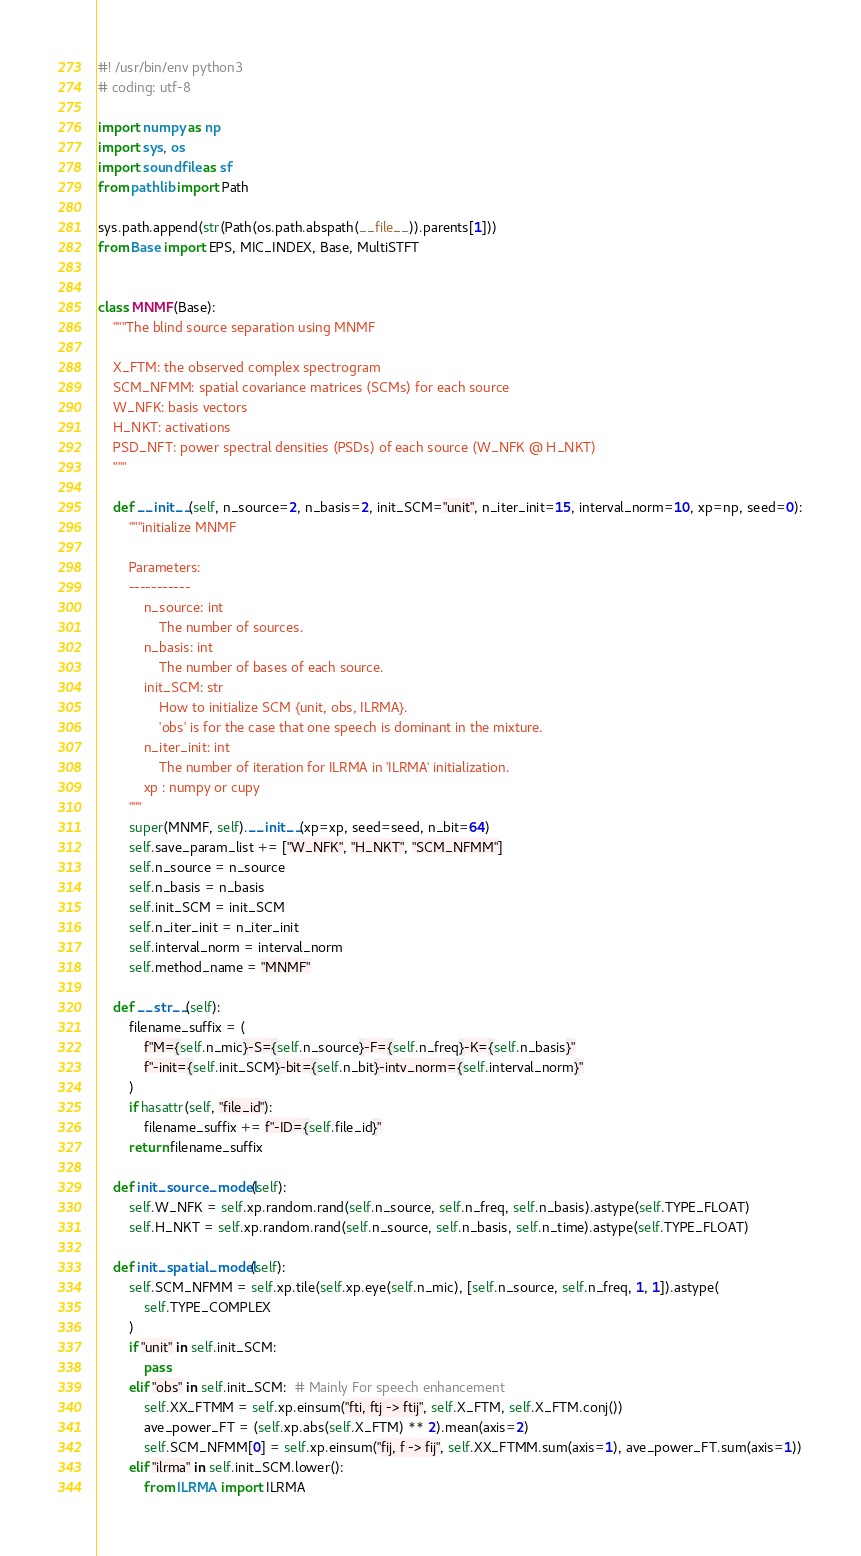<code> <loc_0><loc_0><loc_500><loc_500><_Python_>#! /usr/bin/env python3
# coding: utf-8

import numpy as np
import sys, os
import soundfile as sf
from pathlib import Path

sys.path.append(str(Path(os.path.abspath(__file__)).parents[1]))
from Base import EPS, MIC_INDEX, Base, MultiSTFT


class MNMF(Base):
    """The blind source separation using MNMF

    X_FTM: the observed complex spectrogram
    SCM_NFMM: spatial covariance matrices (SCMs) for each source
    W_NFK: basis vectors
    H_NKT: activations
    PSD_NFT: power spectral densities (PSDs) of each source (W_NFK @ H_NKT)
    """

    def __init__(self, n_source=2, n_basis=2, init_SCM="unit", n_iter_init=15, interval_norm=10, xp=np, seed=0):
        """initialize MNMF

        Parameters:
        -----------
            n_source: int
                The number of sources.
            n_basis: int
                The number of bases of each source.
            init_SCM: str
                How to initialize SCM {unit, obs, ILRMA}.
                'obs' is for the case that one speech is dominant in the mixture.
            n_iter_init: int
                The number of iteration for ILRMA in 'ILRMA' initialization.
            xp : numpy or cupy
        """
        super(MNMF, self).__init__(xp=xp, seed=seed, n_bit=64)
        self.save_param_list += ["W_NFK", "H_NKT", "SCM_NFMM"]
        self.n_source = n_source
        self.n_basis = n_basis
        self.init_SCM = init_SCM
        self.n_iter_init = n_iter_init
        self.interval_norm = interval_norm
        self.method_name = "MNMF"

    def __str__(self):
        filename_suffix = (
            f"M={self.n_mic}-S={self.n_source}-F={self.n_freq}-K={self.n_basis}"
            f"-init={self.init_SCM}-bit={self.n_bit}-intv_norm={self.interval_norm}"
        )
        if hasattr(self, "file_id"):
            filename_suffix += f"-ID={self.file_id}"
        return filename_suffix

    def init_source_model(self):
        self.W_NFK = self.xp.random.rand(self.n_source, self.n_freq, self.n_basis).astype(self.TYPE_FLOAT)
        self.H_NKT = self.xp.random.rand(self.n_source, self.n_basis, self.n_time).astype(self.TYPE_FLOAT)

    def init_spatial_model(self):
        self.SCM_NFMM = self.xp.tile(self.xp.eye(self.n_mic), [self.n_source, self.n_freq, 1, 1]).astype(
            self.TYPE_COMPLEX
        )
        if "unit" in self.init_SCM:
            pass
        elif "obs" in self.init_SCM:  # Mainly For speech enhancement
            self.XX_FTMM = self.xp.einsum("fti, ftj -> ftij", self.X_FTM, self.X_FTM.conj())
            ave_power_FT = (self.xp.abs(self.X_FTM) ** 2).mean(axis=2)
            self.SCM_NFMM[0] = self.xp.einsum("fij, f -> fij", self.XX_FTMM.sum(axis=1), ave_power_FT.sum(axis=1))
        elif "ilrma" in self.init_SCM.lower():
            from ILRMA import ILRMA
</code> 